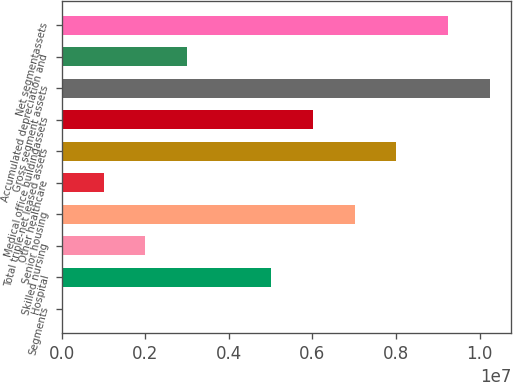Convert chart. <chart><loc_0><loc_0><loc_500><loc_500><bar_chart><fcel>Segments<fcel>Hospital<fcel>Skilled nursing<fcel>Senior housing<fcel>Other healthcare<fcel>Total triple-net leased assets<fcel>Medical office buildingassets<fcel>Gross segment assets<fcel>Accumulated depreciation and<fcel>Net segmentassets<nl><fcel>2006<fcel>5.00738e+06<fcel>2.00415e+06<fcel>7.00953e+06<fcel>1.00308e+06<fcel>8.0106e+06<fcel>6.00845e+06<fcel>1.02509e+07<fcel>3.00523e+06<fcel>9.24979e+06<nl></chart> 